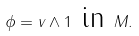Convert formula to latex. <formula><loc_0><loc_0><loc_500><loc_500>\phi = v \wedge 1 \text { in } M .</formula> 